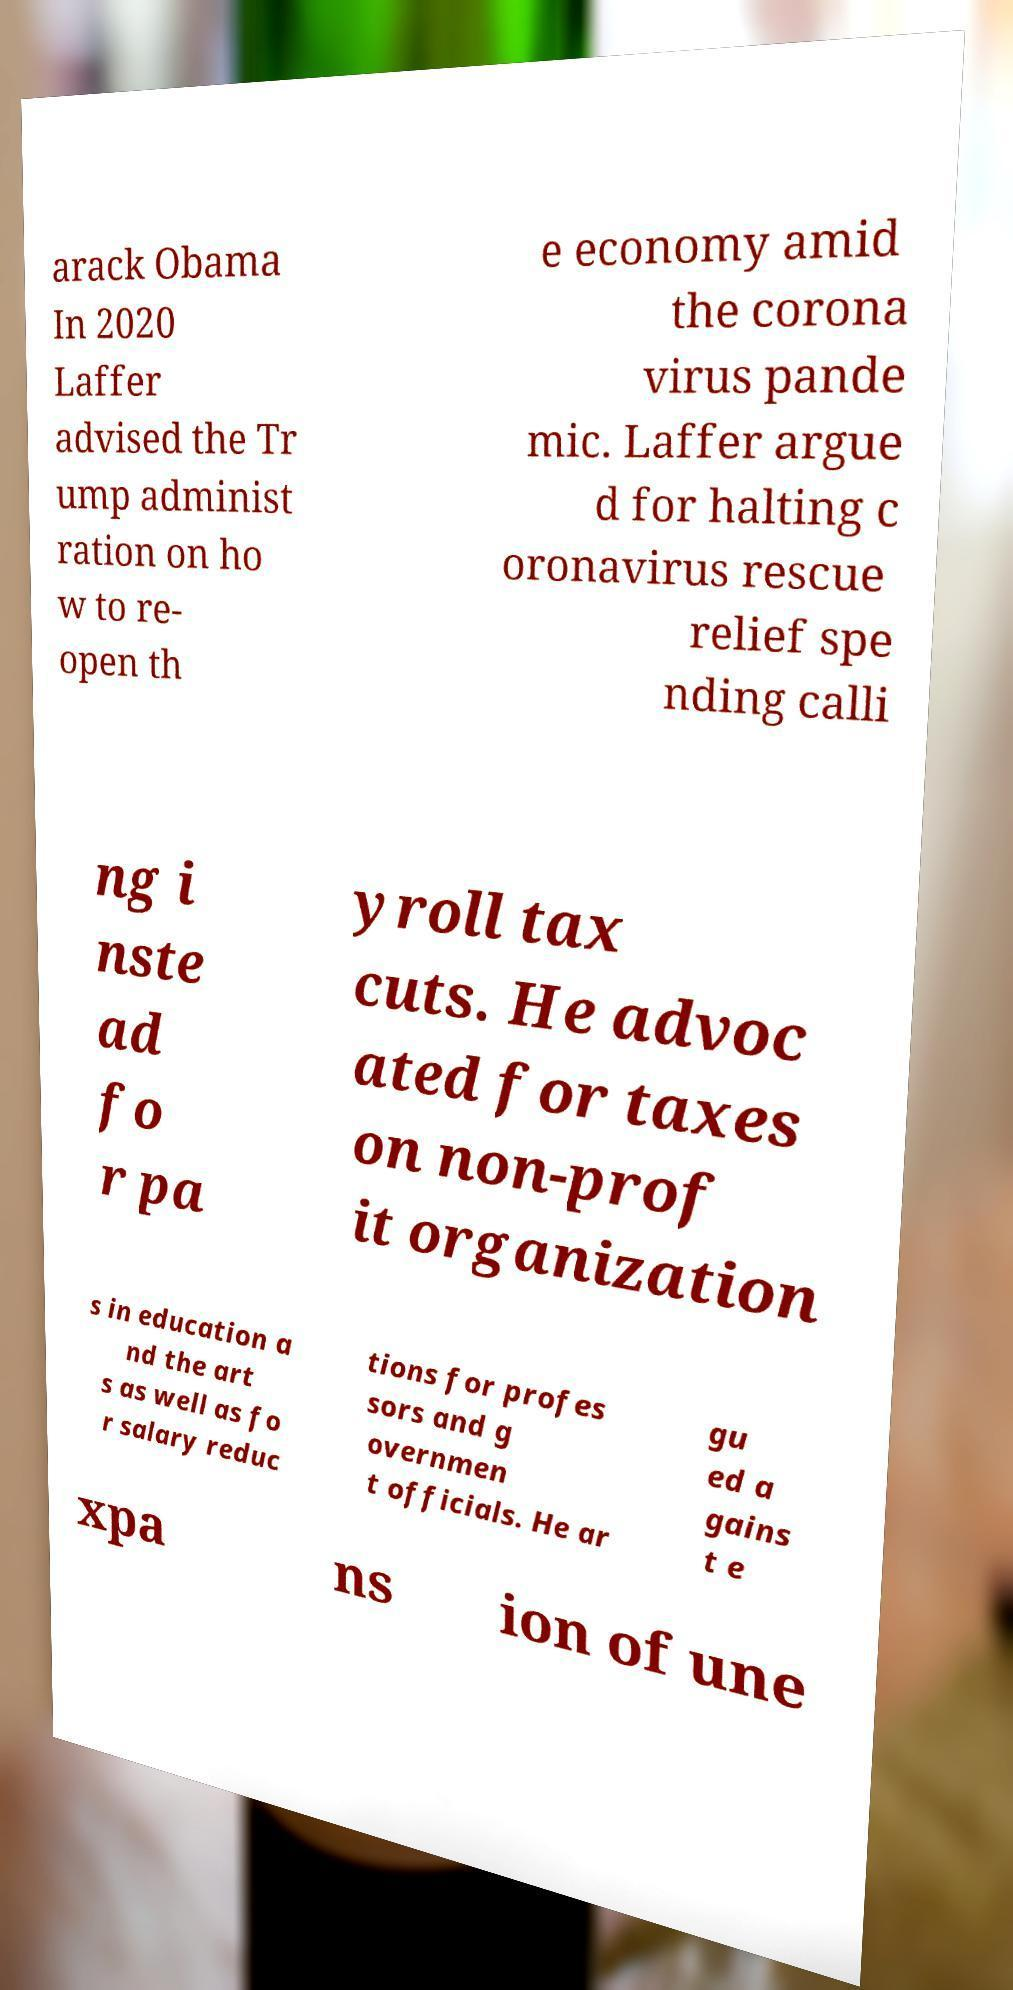Can you accurately transcribe the text from the provided image for me? arack Obama In 2020 Laffer advised the Tr ump administ ration on ho w to re- open th e economy amid the corona virus pande mic. Laffer argue d for halting c oronavirus rescue relief spe nding calli ng i nste ad fo r pa yroll tax cuts. He advoc ated for taxes on non-prof it organization s in education a nd the art s as well as fo r salary reduc tions for profes sors and g overnmen t officials. He ar gu ed a gains t e xpa ns ion of une 